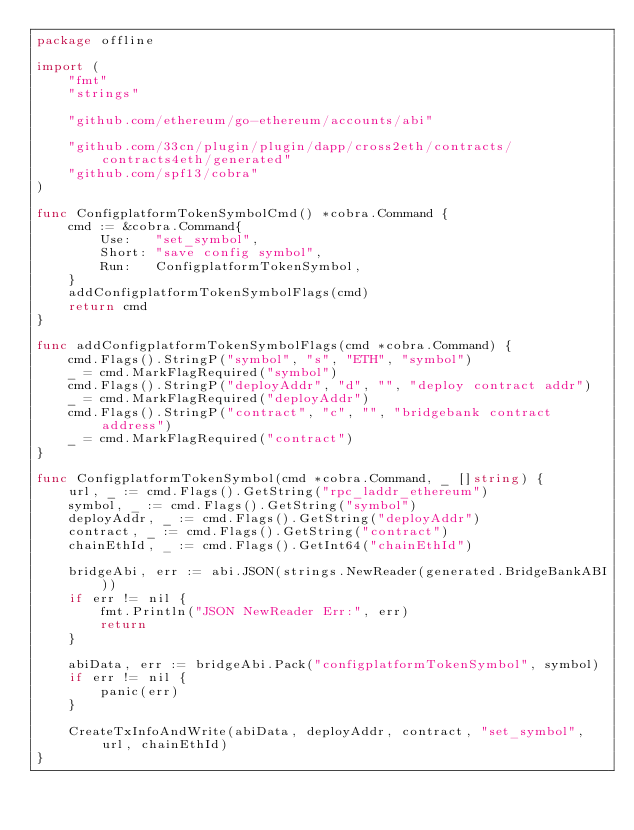<code> <loc_0><loc_0><loc_500><loc_500><_Go_>package offline

import (
	"fmt"
	"strings"

	"github.com/ethereum/go-ethereum/accounts/abi"

	"github.com/33cn/plugin/plugin/dapp/cross2eth/contracts/contracts4eth/generated"
	"github.com/spf13/cobra"
)

func ConfigplatformTokenSymbolCmd() *cobra.Command {
	cmd := &cobra.Command{
		Use:   "set_symbol",
		Short: "save config symbol",
		Run:   ConfigplatformTokenSymbol,
	}
	addConfigplatformTokenSymbolFlags(cmd)
	return cmd
}

func addConfigplatformTokenSymbolFlags(cmd *cobra.Command) {
	cmd.Flags().StringP("symbol", "s", "ETH", "symbol")
	_ = cmd.MarkFlagRequired("symbol")
	cmd.Flags().StringP("deployAddr", "d", "", "deploy contract addr")
	_ = cmd.MarkFlagRequired("deployAddr")
	cmd.Flags().StringP("contract", "c", "", "bridgebank contract address")
	_ = cmd.MarkFlagRequired("contract")
}

func ConfigplatformTokenSymbol(cmd *cobra.Command, _ []string) {
	url, _ := cmd.Flags().GetString("rpc_laddr_ethereum")
	symbol, _ := cmd.Flags().GetString("symbol")
	deployAddr, _ := cmd.Flags().GetString("deployAddr")
	contract, _ := cmd.Flags().GetString("contract")
	chainEthId, _ := cmd.Flags().GetInt64("chainEthId")

	bridgeAbi, err := abi.JSON(strings.NewReader(generated.BridgeBankABI))
	if err != nil {
		fmt.Println("JSON NewReader Err:", err)
		return
	}

	abiData, err := bridgeAbi.Pack("configplatformTokenSymbol", symbol)
	if err != nil {
		panic(err)
	}

	CreateTxInfoAndWrite(abiData, deployAddr, contract, "set_symbol", url, chainEthId)
}
</code> 